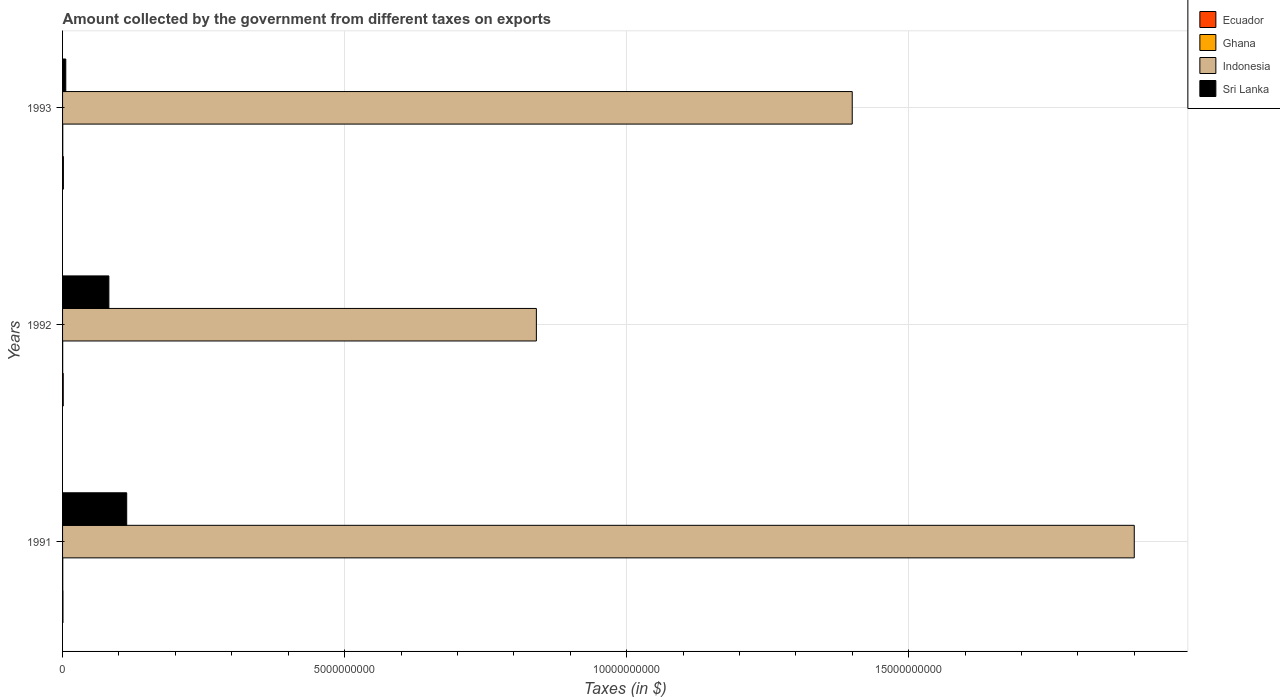Are the number of bars on each tick of the Y-axis equal?
Provide a succinct answer. Yes. How many bars are there on the 2nd tick from the top?
Offer a very short reply. 4. What is the label of the 3rd group of bars from the top?
Provide a short and direct response. 1991. In how many cases, is the number of bars for a given year not equal to the number of legend labels?
Your answer should be compact. 0. What is the amount collected by the government from taxes on exports in Indonesia in 1992?
Make the answer very short. 8.40e+09. Across all years, what is the maximum amount collected by the government from taxes on exports in Ghana?
Your answer should be compact. 3.62e+06. In which year was the amount collected by the government from taxes on exports in Ghana maximum?
Ensure brevity in your answer.  1991. What is the total amount collected by the government from taxes on exports in Ghana in the graph?
Give a very brief answer. 9.23e+06. What is the difference between the amount collected by the government from taxes on exports in Sri Lanka in 1991 and that in 1992?
Ensure brevity in your answer.  3.16e+08. What is the difference between the amount collected by the government from taxes on exports in Ghana in 1993 and the amount collected by the government from taxes on exports in Indonesia in 1991?
Ensure brevity in your answer.  -1.90e+1. What is the average amount collected by the government from taxes on exports in Ghana per year?
Give a very brief answer. 3.08e+06. In the year 1993, what is the difference between the amount collected by the government from taxes on exports in Ghana and amount collected by the government from taxes on exports in Ecuador?
Keep it short and to the point. -1.14e+07. In how many years, is the amount collected by the government from taxes on exports in Sri Lanka greater than 16000000000 $?
Offer a terse response. 0. What is the ratio of the amount collected by the government from taxes on exports in Indonesia in 1991 to that in 1992?
Make the answer very short. 2.26. Is the amount collected by the government from taxes on exports in Ecuador in 1992 less than that in 1993?
Give a very brief answer. Yes. What is the difference between the highest and the second highest amount collected by the government from taxes on exports in Ghana?
Your answer should be compact. 4.05e+04. What is the difference between the highest and the lowest amount collected by the government from taxes on exports in Sri Lanka?
Your answer should be very brief. 1.08e+09. Is the sum of the amount collected by the government from taxes on exports in Ecuador in 1992 and 1993 greater than the maximum amount collected by the government from taxes on exports in Ghana across all years?
Offer a terse response. Yes. Is it the case that in every year, the sum of the amount collected by the government from taxes on exports in Ecuador and amount collected by the government from taxes on exports in Indonesia is greater than the sum of amount collected by the government from taxes on exports in Ghana and amount collected by the government from taxes on exports in Sri Lanka?
Offer a very short reply. Yes. What does the 3rd bar from the bottom in 1993 represents?
Make the answer very short. Indonesia. Is it the case that in every year, the sum of the amount collected by the government from taxes on exports in Ecuador and amount collected by the government from taxes on exports in Ghana is greater than the amount collected by the government from taxes on exports in Sri Lanka?
Your answer should be compact. No. How many bars are there?
Offer a terse response. 12. How many years are there in the graph?
Provide a succinct answer. 3. Are the values on the major ticks of X-axis written in scientific E-notation?
Provide a succinct answer. No. Does the graph contain any zero values?
Your response must be concise. No. Where does the legend appear in the graph?
Provide a short and direct response. Top right. How many legend labels are there?
Your answer should be very brief. 4. How are the legend labels stacked?
Ensure brevity in your answer.  Vertical. What is the title of the graph?
Keep it short and to the point. Amount collected by the government from different taxes on exports. Does "Ecuador" appear as one of the legend labels in the graph?
Provide a succinct answer. Yes. What is the label or title of the X-axis?
Keep it short and to the point. Taxes (in $). What is the Taxes (in $) of Ecuador in 1991?
Ensure brevity in your answer.  7.00e+06. What is the Taxes (in $) of Ghana in 1991?
Offer a terse response. 3.62e+06. What is the Taxes (in $) of Indonesia in 1991?
Your response must be concise. 1.90e+1. What is the Taxes (in $) of Sri Lanka in 1991?
Provide a succinct answer. 1.14e+09. What is the Taxes (in $) in Ghana in 1992?
Offer a very short reply. 2.04e+06. What is the Taxes (in $) of Indonesia in 1992?
Your answer should be compact. 8.40e+09. What is the Taxes (in $) of Sri Lanka in 1992?
Make the answer very short. 8.21e+08. What is the Taxes (in $) in Ecuador in 1993?
Your answer should be compact. 1.50e+07. What is the Taxes (in $) in Ghana in 1993?
Give a very brief answer. 3.57e+06. What is the Taxes (in $) of Indonesia in 1993?
Provide a short and direct response. 1.40e+1. What is the Taxes (in $) of Sri Lanka in 1993?
Ensure brevity in your answer.  5.70e+07. Across all years, what is the maximum Taxes (in $) of Ecuador?
Offer a very short reply. 1.50e+07. Across all years, what is the maximum Taxes (in $) in Ghana?
Keep it short and to the point. 3.62e+06. Across all years, what is the maximum Taxes (in $) of Indonesia?
Keep it short and to the point. 1.90e+1. Across all years, what is the maximum Taxes (in $) in Sri Lanka?
Make the answer very short. 1.14e+09. Across all years, what is the minimum Taxes (in $) of Ghana?
Your answer should be very brief. 2.04e+06. Across all years, what is the minimum Taxes (in $) in Indonesia?
Make the answer very short. 8.40e+09. Across all years, what is the minimum Taxes (in $) of Sri Lanka?
Ensure brevity in your answer.  5.70e+07. What is the total Taxes (in $) of Ecuador in the graph?
Provide a succinct answer. 3.40e+07. What is the total Taxes (in $) in Ghana in the graph?
Make the answer very short. 9.23e+06. What is the total Taxes (in $) of Indonesia in the graph?
Your answer should be compact. 4.14e+1. What is the total Taxes (in $) of Sri Lanka in the graph?
Your answer should be compact. 2.02e+09. What is the difference between the Taxes (in $) in Ecuador in 1991 and that in 1992?
Give a very brief answer. -5.00e+06. What is the difference between the Taxes (in $) of Ghana in 1991 and that in 1992?
Your response must be concise. 1.58e+06. What is the difference between the Taxes (in $) in Indonesia in 1991 and that in 1992?
Your answer should be very brief. 1.06e+1. What is the difference between the Taxes (in $) in Sri Lanka in 1991 and that in 1992?
Provide a short and direct response. 3.16e+08. What is the difference between the Taxes (in $) of Ecuador in 1991 and that in 1993?
Provide a short and direct response. -8.00e+06. What is the difference between the Taxes (in $) of Ghana in 1991 and that in 1993?
Make the answer very short. 4.05e+04. What is the difference between the Taxes (in $) in Indonesia in 1991 and that in 1993?
Keep it short and to the point. 5.00e+09. What is the difference between the Taxes (in $) in Sri Lanka in 1991 and that in 1993?
Provide a short and direct response. 1.08e+09. What is the difference between the Taxes (in $) in Ghana in 1992 and that in 1993?
Keep it short and to the point. -1.54e+06. What is the difference between the Taxes (in $) in Indonesia in 1992 and that in 1993?
Offer a very short reply. -5.60e+09. What is the difference between the Taxes (in $) of Sri Lanka in 1992 and that in 1993?
Provide a short and direct response. 7.64e+08. What is the difference between the Taxes (in $) of Ecuador in 1991 and the Taxes (in $) of Ghana in 1992?
Give a very brief answer. 4.96e+06. What is the difference between the Taxes (in $) in Ecuador in 1991 and the Taxes (in $) in Indonesia in 1992?
Your answer should be very brief. -8.39e+09. What is the difference between the Taxes (in $) in Ecuador in 1991 and the Taxes (in $) in Sri Lanka in 1992?
Provide a succinct answer. -8.14e+08. What is the difference between the Taxes (in $) of Ghana in 1991 and the Taxes (in $) of Indonesia in 1992?
Provide a short and direct response. -8.40e+09. What is the difference between the Taxes (in $) in Ghana in 1991 and the Taxes (in $) in Sri Lanka in 1992?
Keep it short and to the point. -8.17e+08. What is the difference between the Taxes (in $) in Indonesia in 1991 and the Taxes (in $) in Sri Lanka in 1992?
Your response must be concise. 1.82e+1. What is the difference between the Taxes (in $) of Ecuador in 1991 and the Taxes (in $) of Ghana in 1993?
Make the answer very short. 3.43e+06. What is the difference between the Taxes (in $) in Ecuador in 1991 and the Taxes (in $) in Indonesia in 1993?
Make the answer very short. -1.40e+1. What is the difference between the Taxes (in $) in Ecuador in 1991 and the Taxes (in $) in Sri Lanka in 1993?
Make the answer very short. -5.00e+07. What is the difference between the Taxes (in $) in Ghana in 1991 and the Taxes (in $) in Indonesia in 1993?
Offer a terse response. -1.40e+1. What is the difference between the Taxes (in $) in Ghana in 1991 and the Taxes (in $) in Sri Lanka in 1993?
Offer a very short reply. -5.34e+07. What is the difference between the Taxes (in $) in Indonesia in 1991 and the Taxes (in $) in Sri Lanka in 1993?
Your response must be concise. 1.89e+1. What is the difference between the Taxes (in $) in Ecuador in 1992 and the Taxes (in $) in Ghana in 1993?
Your answer should be compact. 8.43e+06. What is the difference between the Taxes (in $) of Ecuador in 1992 and the Taxes (in $) of Indonesia in 1993?
Make the answer very short. -1.40e+1. What is the difference between the Taxes (in $) in Ecuador in 1992 and the Taxes (in $) in Sri Lanka in 1993?
Your response must be concise. -4.50e+07. What is the difference between the Taxes (in $) in Ghana in 1992 and the Taxes (in $) in Indonesia in 1993?
Your response must be concise. -1.40e+1. What is the difference between the Taxes (in $) in Ghana in 1992 and the Taxes (in $) in Sri Lanka in 1993?
Offer a terse response. -5.50e+07. What is the difference between the Taxes (in $) of Indonesia in 1992 and the Taxes (in $) of Sri Lanka in 1993?
Your response must be concise. 8.34e+09. What is the average Taxes (in $) of Ecuador per year?
Make the answer very short. 1.13e+07. What is the average Taxes (in $) of Ghana per year?
Give a very brief answer. 3.08e+06. What is the average Taxes (in $) in Indonesia per year?
Ensure brevity in your answer.  1.38e+1. What is the average Taxes (in $) of Sri Lanka per year?
Your answer should be very brief. 6.72e+08. In the year 1991, what is the difference between the Taxes (in $) of Ecuador and Taxes (in $) of Ghana?
Offer a very short reply. 3.38e+06. In the year 1991, what is the difference between the Taxes (in $) of Ecuador and Taxes (in $) of Indonesia?
Your answer should be very brief. -1.90e+1. In the year 1991, what is the difference between the Taxes (in $) of Ecuador and Taxes (in $) of Sri Lanka?
Your response must be concise. -1.13e+09. In the year 1991, what is the difference between the Taxes (in $) in Ghana and Taxes (in $) in Indonesia?
Offer a terse response. -1.90e+1. In the year 1991, what is the difference between the Taxes (in $) of Ghana and Taxes (in $) of Sri Lanka?
Keep it short and to the point. -1.13e+09. In the year 1991, what is the difference between the Taxes (in $) in Indonesia and Taxes (in $) in Sri Lanka?
Provide a short and direct response. 1.79e+1. In the year 1992, what is the difference between the Taxes (in $) in Ecuador and Taxes (in $) in Ghana?
Your answer should be compact. 9.96e+06. In the year 1992, what is the difference between the Taxes (in $) of Ecuador and Taxes (in $) of Indonesia?
Make the answer very short. -8.39e+09. In the year 1992, what is the difference between the Taxes (in $) of Ecuador and Taxes (in $) of Sri Lanka?
Give a very brief answer. -8.09e+08. In the year 1992, what is the difference between the Taxes (in $) of Ghana and Taxes (in $) of Indonesia?
Make the answer very short. -8.40e+09. In the year 1992, what is the difference between the Taxes (in $) of Ghana and Taxes (in $) of Sri Lanka?
Offer a very short reply. -8.19e+08. In the year 1992, what is the difference between the Taxes (in $) of Indonesia and Taxes (in $) of Sri Lanka?
Ensure brevity in your answer.  7.58e+09. In the year 1993, what is the difference between the Taxes (in $) of Ecuador and Taxes (in $) of Ghana?
Keep it short and to the point. 1.14e+07. In the year 1993, what is the difference between the Taxes (in $) of Ecuador and Taxes (in $) of Indonesia?
Your answer should be compact. -1.40e+1. In the year 1993, what is the difference between the Taxes (in $) in Ecuador and Taxes (in $) in Sri Lanka?
Provide a succinct answer. -4.20e+07. In the year 1993, what is the difference between the Taxes (in $) in Ghana and Taxes (in $) in Indonesia?
Offer a terse response. -1.40e+1. In the year 1993, what is the difference between the Taxes (in $) of Ghana and Taxes (in $) of Sri Lanka?
Your response must be concise. -5.34e+07. In the year 1993, what is the difference between the Taxes (in $) of Indonesia and Taxes (in $) of Sri Lanka?
Keep it short and to the point. 1.39e+1. What is the ratio of the Taxes (in $) of Ecuador in 1991 to that in 1992?
Provide a succinct answer. 0.58. What is the ratio of the Taxes (in $) of Ghana in 1991 to that in 1992?
Your answer should be very brief. 1.78. What is the ratio of the Taxes (in $) of Indonesia in 1991 to that in 1992?
Make the answer very short. 2.26. What is the ratio of the Taxes (in $) of Sri Lanka in 1991 to that in 1992?
Offer a terse response. 1.38. What is the ratio of the Taxes (in $) in Ecuador in 1991 to that in 1993?
Provide a succinct answer. 0.47. What is the ratio of the Taxes (in $) in Ghana in 1991 to that in 1993?
Provide a succinct answer. 1.01. What is the ratio of the Taxes (in $) in Indonesia in 1991 to that in 1993?
Give a very brief answer. 1.36. What is the ratio of the Taxes (in $) in Sri Lanka in 1991 to that in 1993?
Give a very brief answer. 19.95. What is the ratio of the Taxes (in $) in Ghana in 1992 to that in 1993?
Give a very brief answer. 0.57. What is the ratio of the Taxes (in $) of Sri Lanka in 1992 to that in 1993?
Keep it short and to the point. 14.4. What is the difference between the highest and the second highest Taxes (in $) in Ecuador?
Make the answer very short. 3.00e+06. What is the difference between the highest and the second highest Taxes (in $) of Ghana?
Offer a very short reply. 4.05e+04. What is the difference between the highest and the second highest Taxes (in $) of Sri Lanka?
Provide a succinct answer. 3.16e+08. What is the difference between the highest and the lowest Taxes (in $) in Ecuador?
Offer a terse response. 8.00e+06. What is the difference between the highest and the lowest Taxes (in $) of Ghana?
Keep it short and to the point. 1.58e+06. What is the difference between the highest and the lowest Taxes (in $) of Indonesia?
Ensure brevity in your answer.  1.06e+1. What is the difference between the highest and the lowest Taxes (in $) in Sri Lanka?
Make the answer very short. 1.08e+09. 